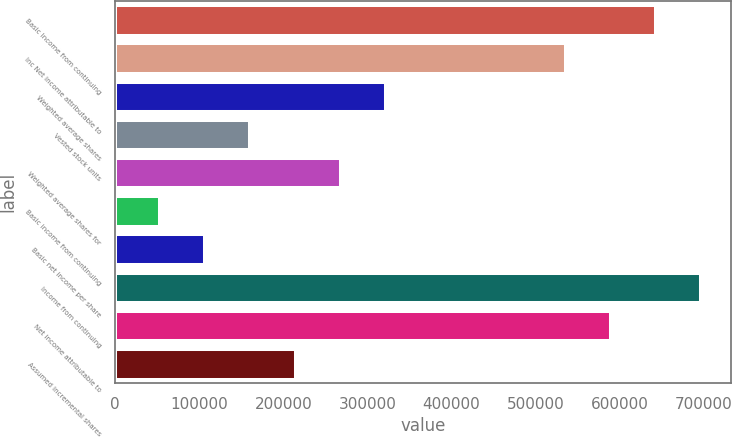Convert chart to OTSL. <chart><loc_0><loc_0><loc_500><loc_500><bar_chart><fcel>Basic Income from continuing<fcel>Inc Net income attributable to<fcel>Weighted average shares<fcel>Vested stock units<fcel>Weighted average shares for<fcel>Basic income from continuing<fcel>Basic net income per share<fcel>Income from continuing<fcel>Net income attributable to<fcel>Assumed incremental shares<nl><fcel>643264<fcel>536017<fcel>321743<fcel>160873<fcel>268119<fcel>53626.1<fcel>107249<fcel>696887<fcel>589640<fcel>214496<nl></chart> 